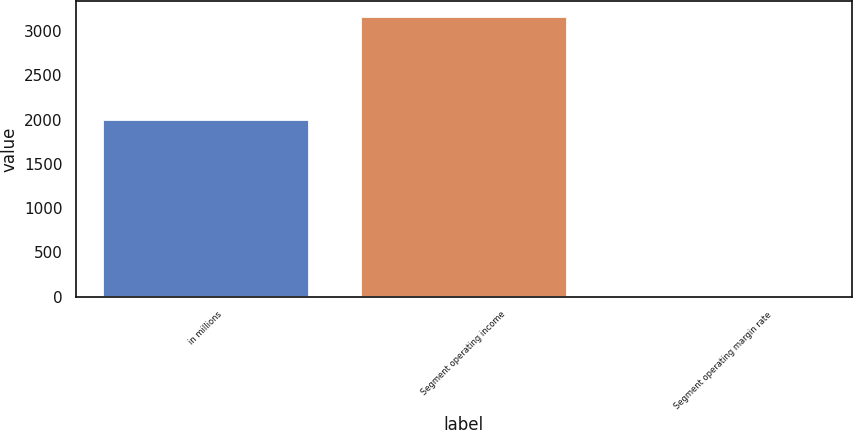Convert chart to OTSL. <chart><loc_0><loc_0><loc_500><loc_500><bar_chart><fcel>in millions<fcel>Segment operating income<fcel>Segment operating margin rate<nl><fcel>2012<fcel>3176<fcel>12.6<nl></chart> 